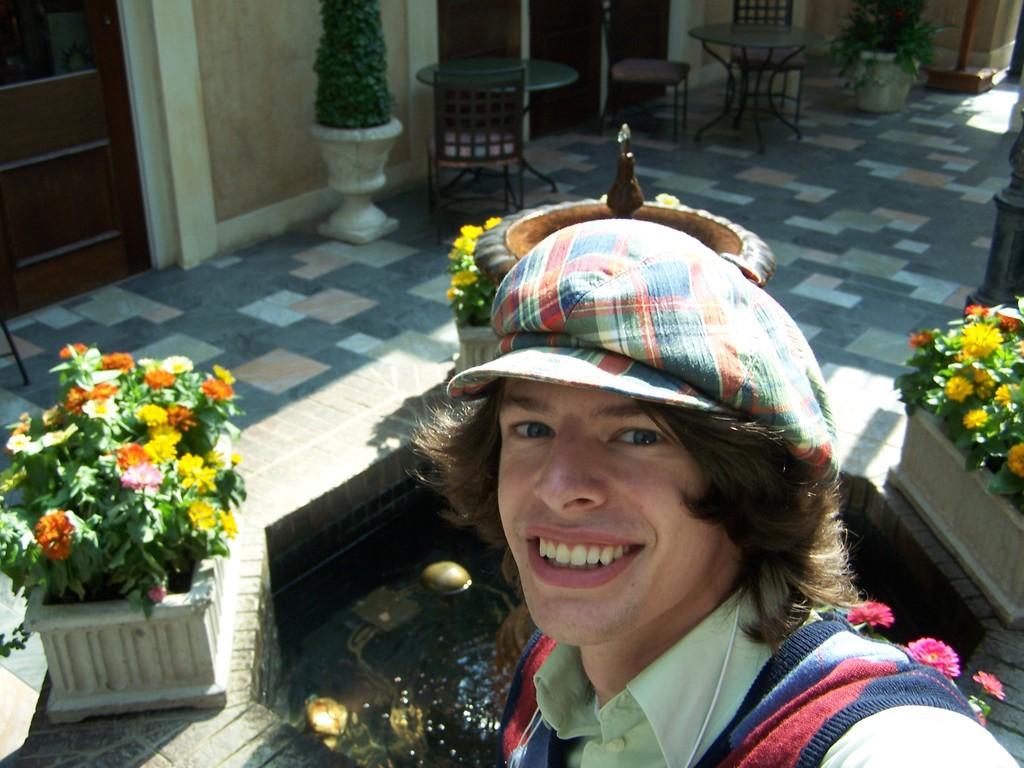Describe this image in one or two sentences. There is a person standing and there is a fountain flowers,tables,chairs behind him. 